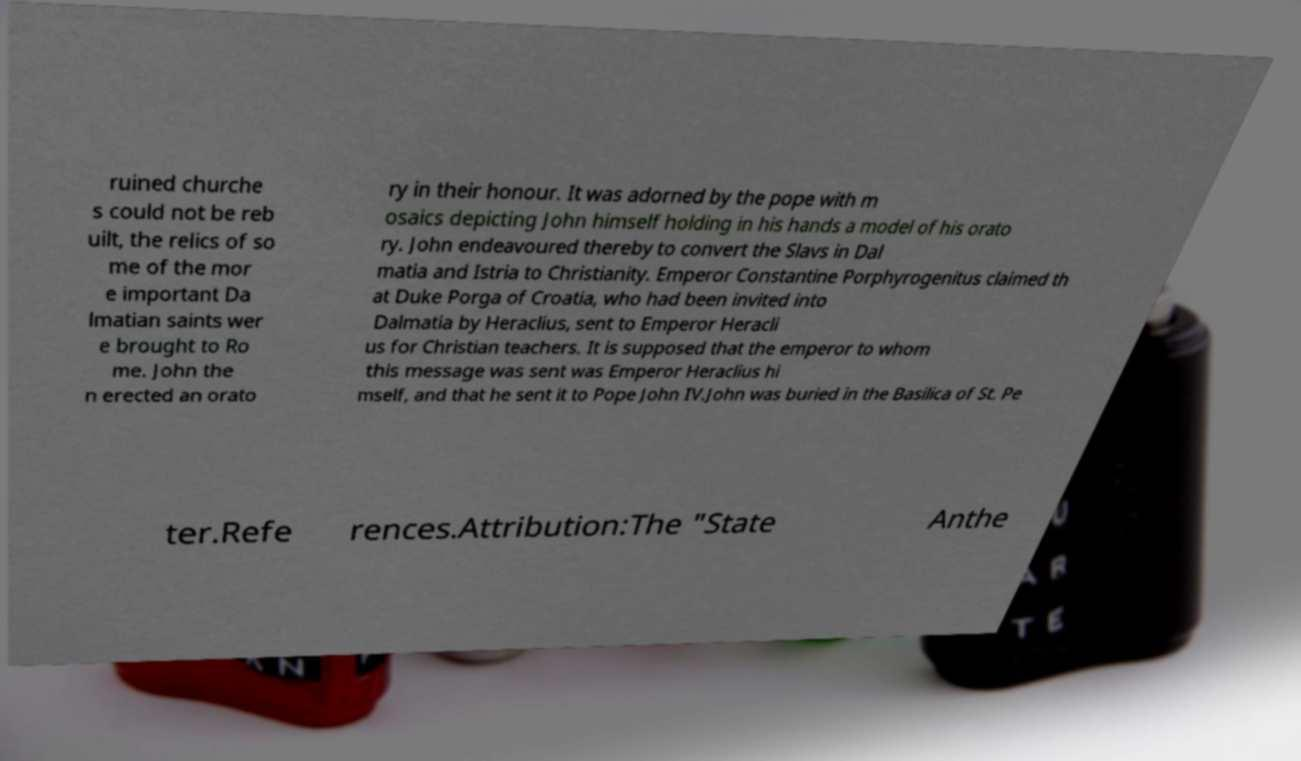Could you extract and type out the text from this image? ruined churche s could not be reb uilt, the relics of so me of the mor e important Da lmatian saints wer e brought to Ro me. John the n erected an orato ry in their honour. It was adorned by the pope with m osaics depicting John himself holding in his hands a model of his orato ry. John endeavoured thereby to convert the Slavs in Dal matia and Istria to Christianity. Emperor Constantine Porphyrogenitus claimed th at Duke Porga of Croatia, who had been invited into Dalmatia by Heraclius, sent to Emperor Heracli us for Christian teachers. It is supposed that the emperor to whom this message was sent was Emperor Heraclius hi mself, and that he sent it to Pope John IV.John was buried in the Basilica of St. Pe ter.Refe rences.Attribution:The "State Anthe 